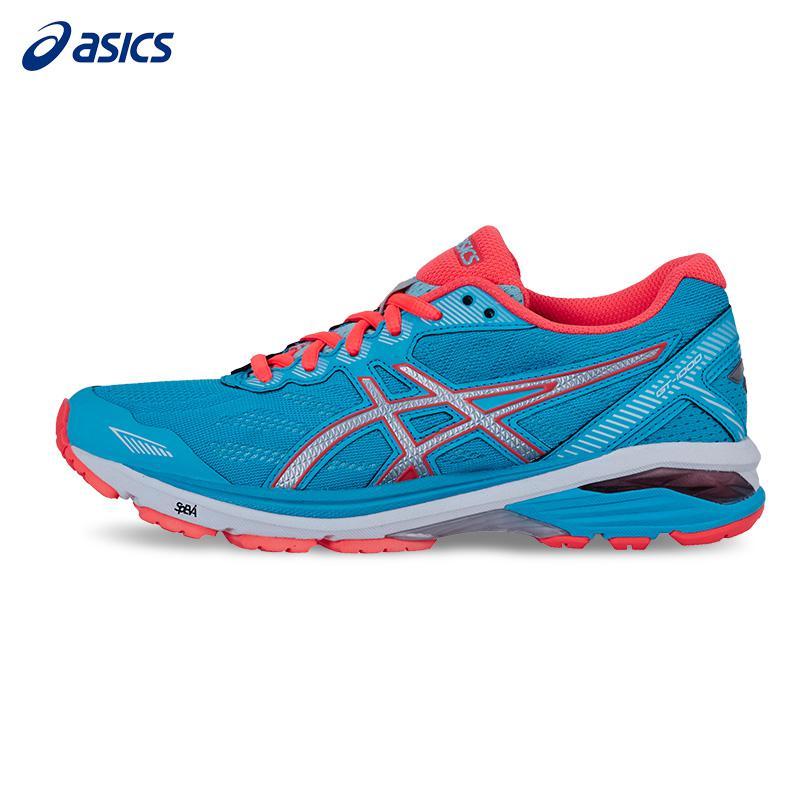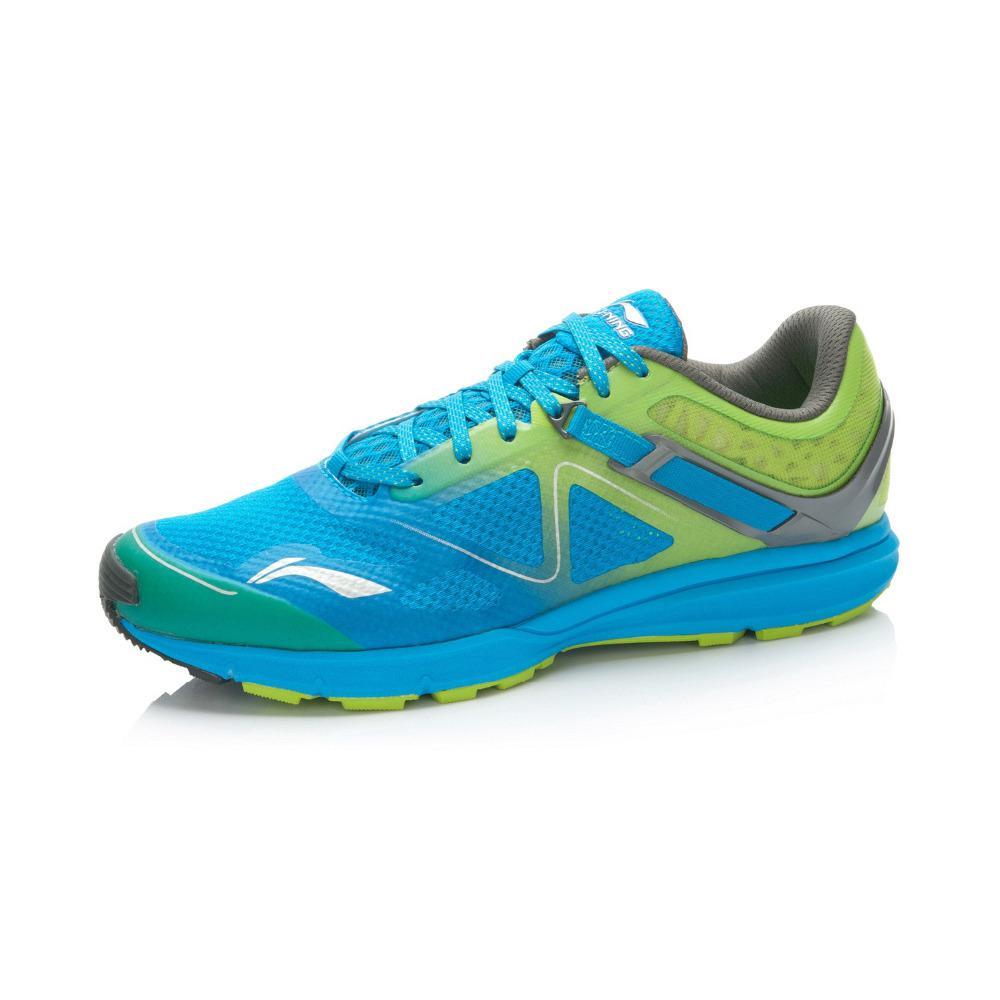The first image is the image on the left, the second image is the image on the right. Evaluate the accuracy of this statement regarding the images: "In one image, a shoe featuring turquise, gray, and lime green is laced with turquoise colored strings, and is positioned so the toe section is angled towards the front.". Is it true? Answer yes or no. Yes. The first image is the image on the left, the second image is the image on the right. Assess this claim about the two images: "Each image contains a single sneaker, and the sneakers in the right and left images face the same direction.". Correct or not? Answer yes or no. Yes. 